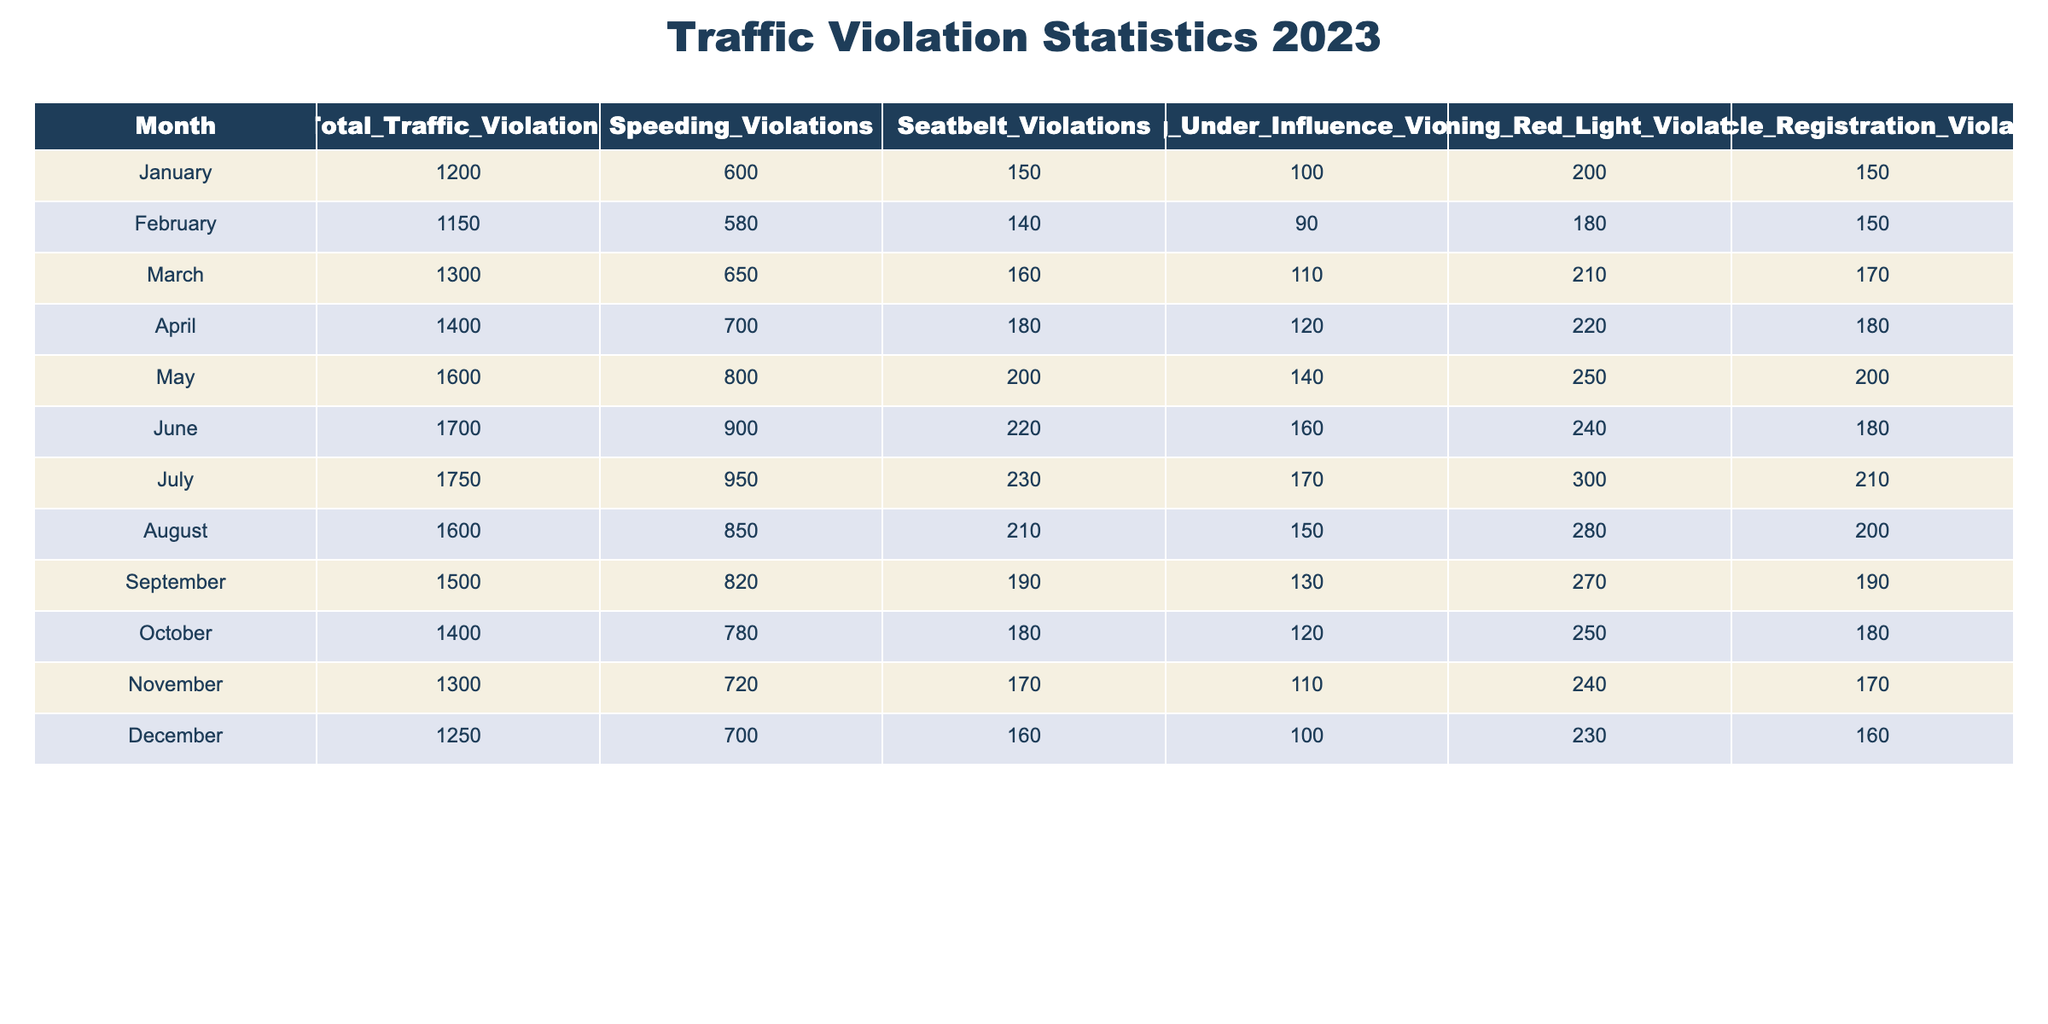What was the total number of traffic violations in May? In the table, I look under the "Total_Traffic_Violations" column for the row corresponding to May. The entry for May indicates that there were 1600 total traffic violations.
Answer: 1600 Which month had the highest number of speeding violations? I check the "Speeding_Violations" column in the table and identify that July has the greatest value, displaying 950 speeding violations.
Answer: July What is the average number of driving under influence violations per month? To find the average, I sum all the values in the "Driving_Under_Influence_Violations" column (100 + 90 + 110 + 120 + 140 + 160 + 170 + 150 + 130 + 120 + 110 + 100 = 1550) and divide by the number of months (12), resulting in 1550 / 12 = 129.17, which rounds to approximately 129.
Answer: 129 Did more than 700 traffic violations occur in December? By referring to the "Total_Traffic_Violations" row for December, I see it lists 1250. Since 1250 is greater than 700, the answer is yes.
Answer: Yes What is the total number of seatbelt violations from January to March combined? I add the seatbelt violations for January (150), February (140), and March (160). Summing these gives 150 + 140 + 160 = 450.
Answer: 450 In which month did the number of vehicle registration violations decrease compared to the previous month? I examine the "Vehicle_Registration_Violations" column. I see that the numbers for May (200) and June (180) show a decrease from 200 to 180. Therefore, the month prior to June (May) had more vehicle registration violations.
Answer: May What is the difference in the number of total violations between June and August? From the "Total_Traffic_Violations" column, June has 1700 violations and August has 1600. The difference is 1700 - 1600 = 100.
Answer: 100 Which month had the least number of driving under influence violations? I check the "Driving_Under_Influence_Violations" column. The minimum occurs in December with 100 recorded violations, which is the lowest across all months.
Answer: December How many total traffic violations occurred in the first quarter (January to March) of 2023? I sum the total traffic violations for January (1200), February (1150), and March (1300). Adding these gives 1200 + 1150 + 1300 = 3650.
Answer: 3650 